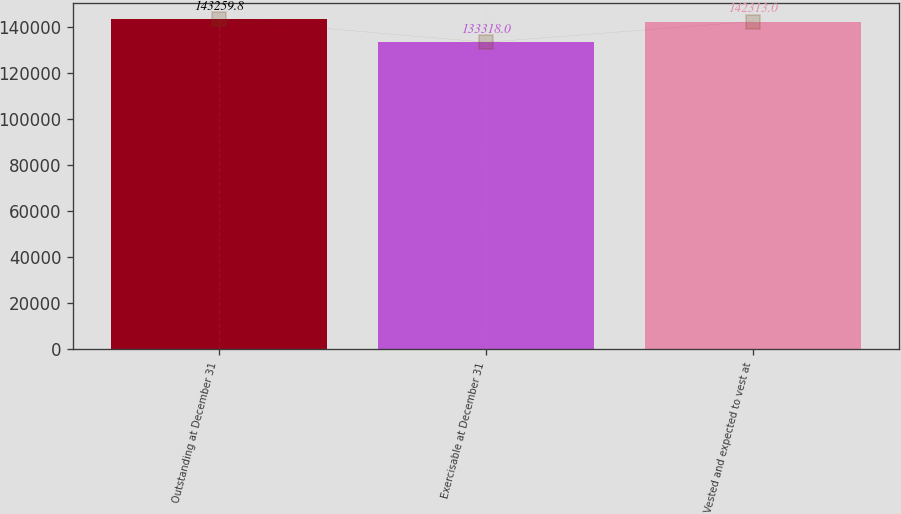Convert chart. <chart><loc_0><loc_0><loc_500><loc_500><bar_chart><fcel>Outstanding at December 31<fcel>Exercisable at December 31<fcel>Vested and expected to vest at<nl><fcel>143260<fcel>133318<fcel>142313<nl></chart> 